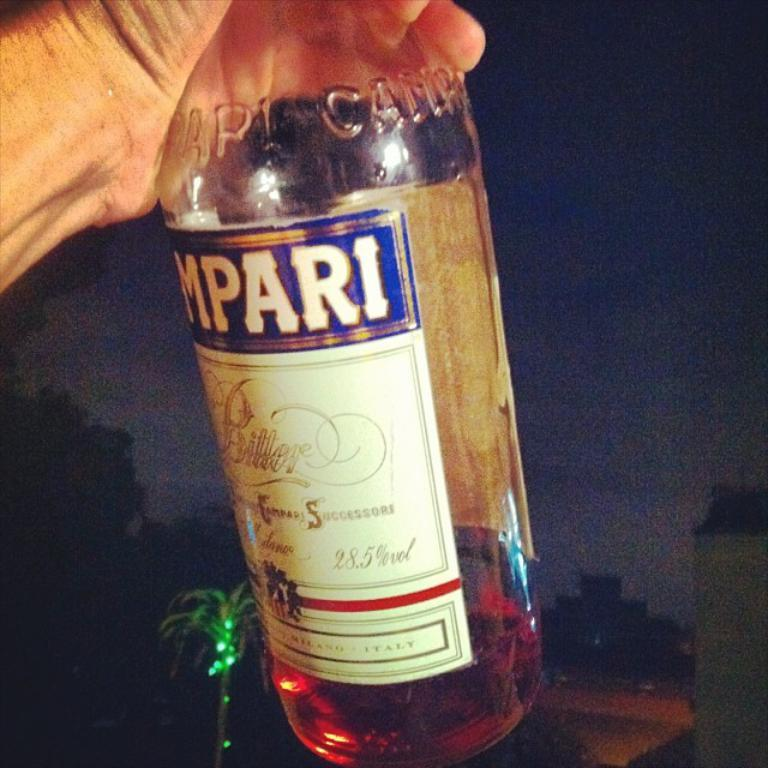<image>
Create a compact narrative representing the image presented. A person is holding a Campari Bitters bottle. 